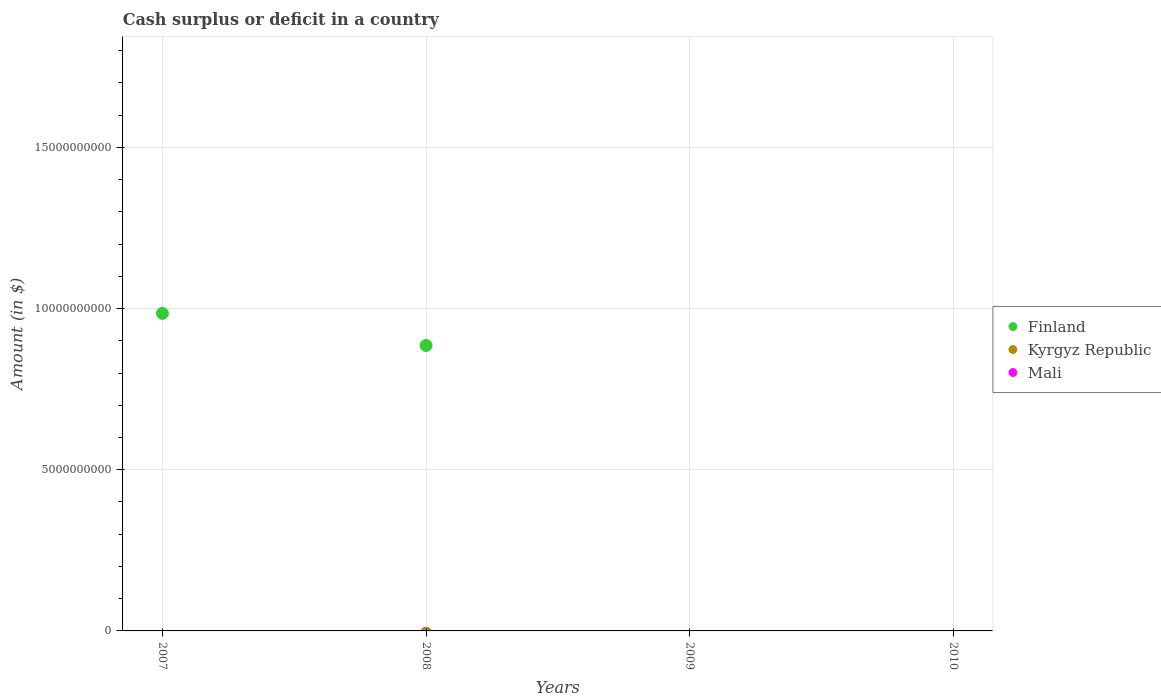How many different coloured dotlines are there?
Your answer should be compact. 1. What is the amount of cash surplus or deficit in Kyrgyz Republic in 2010?
Your answer should be very brief. 0. Across all years, what is the maximum amount of cash surplus or deficit in Finland?
Provide a short and direct response. 9.85e+09. Across all years, what is the minimum amount of cash surplus or deficit in Finland?
Provide a short and direct response. 0. What is the total amount of cash surplus or deficit in Kyrgyz Republic in the graph?
Keep it short and to the point. 0. What is the difference between the highest and the lowest amount of cash surplus or deficit in Finland?
Your answer should be very brief. 9.85e+09. In how many years, is the amount of cash surplus or deficit in Mali greater than the average amount of cash surplus or deficit in Mali taken over all years?
Provide a succinct answer. 0. Is it the case that in every year, the sum of the amount of cash surplus or deficit in Finland and amount of cash surplus or deficit in Mali  is greater than the amount of cash surplus or deficit in Kyrgyz Republic?
Ensure brevity in your answer.  No. Is the amount of cash surplus or deficit in Kyrgyz Republic strictly less than the amount of cash surplus or deficit in Mali over the years?
Ensure brevity in your answer.  No. How many dotlines are there?
Give a very brief answer. 1. What is the difference between two consecutive major ticks on the Y-axis?
Your answer should be compact. 5.00e+09. Does the graph contain grids?
Keep it short and to the point. Yes. Where does the legend appear in the graph?
Make the answer very short. Center right. What is the title of the graph?
Your answer should be compact. Cash surplus or deficit in a country. What is the label or title of the X-axis?
Keep it short and to the point. Years. What is the label or title of the Y-axis?
Offer a very short reply. Amount (in $). What is the Amount (in $) in Finland in 2007?
Give a very brief answer. 9.85e+09. What is the Amount (in $) of Kyrgyz Republic in 2007?
Keep it short and to the point. 0. What is the Amount (in $) in Finland in 2008?
Give a very brief answer. 8.86e+09. What is the Amount (in $) in Kyrgyz Republic in 2009?
Provide a short and direct response. 0. What is the Amount (in $) in Finland in 2010?
Give a very brief answer. 0. What is the Amount (in $) in Kyrgyz Republic in 2010?
Provide a short and direct response. 0. Across all years, what is the maximum Amount (in $) of Finland?
Provide a short and direct response. 9.85e+09. Across all years, what is the minimum Amount (in $) in Finland?
Offer a very short reply. 0. What is the total Amount (in $) of Finland in the graph?
Ensure brevity in your answer.  1.87e+1. What is the total Amount (in $) in Mali in the graph?
Your answer should be very brief. 0. What is the difference between the Amount (in $) in Finland in 2007 and that in 2008?
Ensure brevity in your answer.  9.96e+08. What is the average Amount (in $) in Finland per year?
Ensure brevity in your answer.  4.68e+09. What is the average Amount (in $) of Kyrgyz Republic per year?
Give a very brief answer. 0. What is the average Amount (in $) of Mali per year?
Offer a terse response. 0. What is the ratio of the Amount (in $) in Finland in 2007 to that in 2008?
Your answer should be very brief. 1.11. What is the difference between the highest and the lowest Amount (in $) in Finland?
Ensure brevity in your answer.  9.85e+09. 